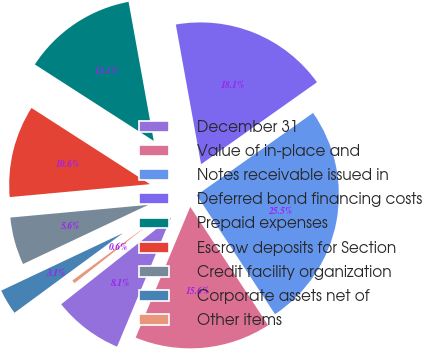Convert chart. <chart><loc_0><loc_0><loc_500><loc_500><pie_chart><fcel>December 31<fcel>Value of in-place and<fcel>Notes receivable issued in<fcel>Deferred bond financing costs<fcel>Prepaid expenses<fcel>Escrow deposits for Section<fcel>Credit facility organization<fcel>Corporate assets net of<fcel>Other items<nl><fcel>8.06%<fcel>15.55%<fcel>25.54%<fcel>18.05%<fcel>13.05%<fcel>10.56%<fcel>5.56%<fcel>3.06%<fcel>0.56%<nl></chart> 